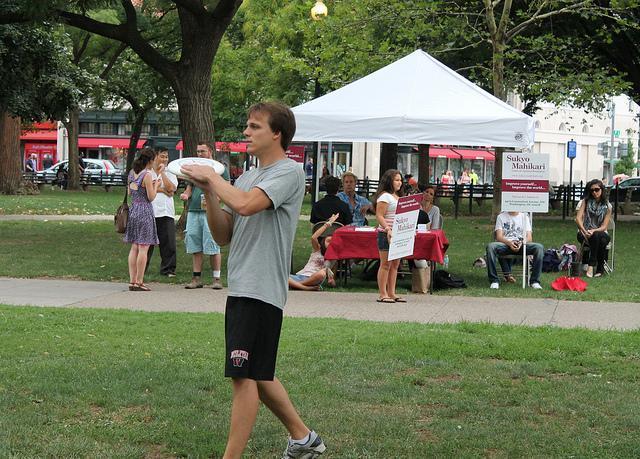How many people can you see?
Give a very brief answer. 7. 